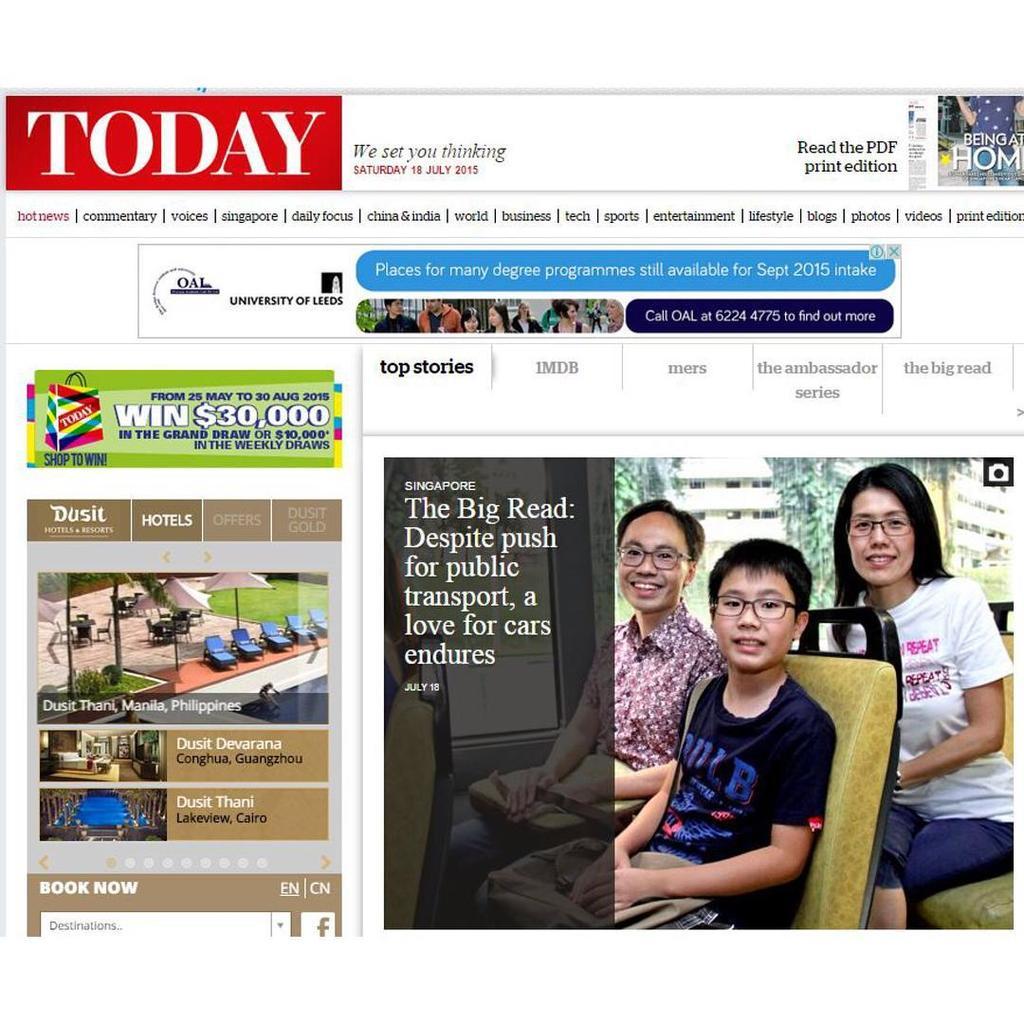How much can you win?
Make the answer very short. $30,000. 